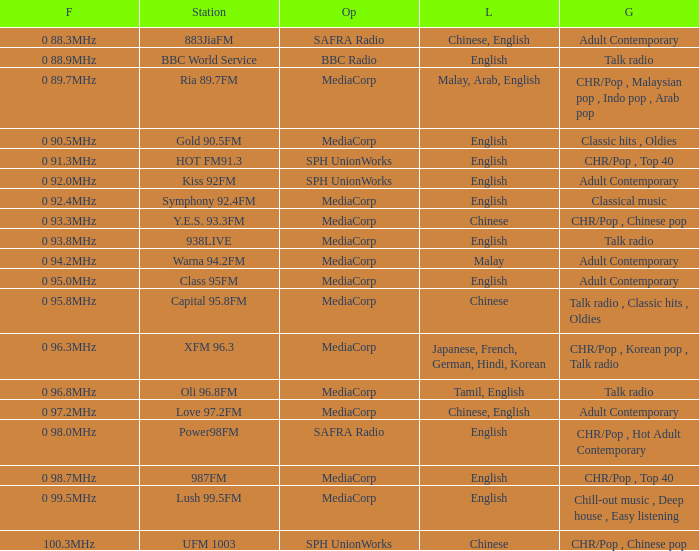What is the classification of the bbc world service? Talk radio. 